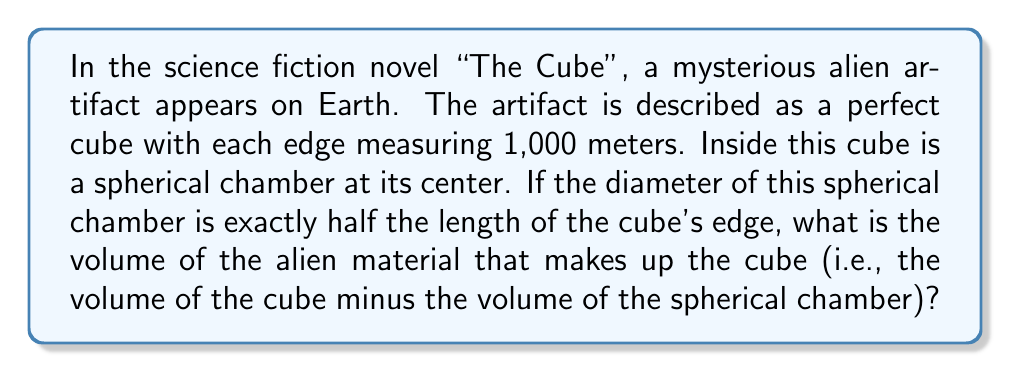Can you solve this math problem? Let's approach this step-by-step:

1) First, let's calculate the volume of the entire cube:
   - Edge length = 1,000 m
   - Volume of cube = $edge^3$ = $1000^3$ = 1,000,000,000 $m^3$

2) Now, let's calculate the volume of the spherical chamber:
   - Diameter of sphere = 1/2 × edge length = 500 m
   - Radius of sphere = 250 m
   - Volume of sphere = $\frac{4}{3}\pi r^3$ = $\frac{4}{3}\pi (250)^3$ = $65,449,846.95$ $m^3$

3) The volume of the alien material is the difference between these volumes:
   Volume of alien material = Volume of cube - Volume of sphere
   $$ V = 1,000,000,000 - 65,449,846.95 = 934,550,153.05 \text{ } m^3 $$

4) Rounding to the nearest whole number:
   $$ V \approx 934,550,153 \text{ } m^3 $$
Answer: 934,550,153 $m^3$ 